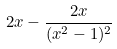<formula> <loc_0><loc_0><loc_500><loc_500>2 x - \frac { 2 x } { ( x ^ { 2 } - 1 ) ^ { 2 } }</formula> 